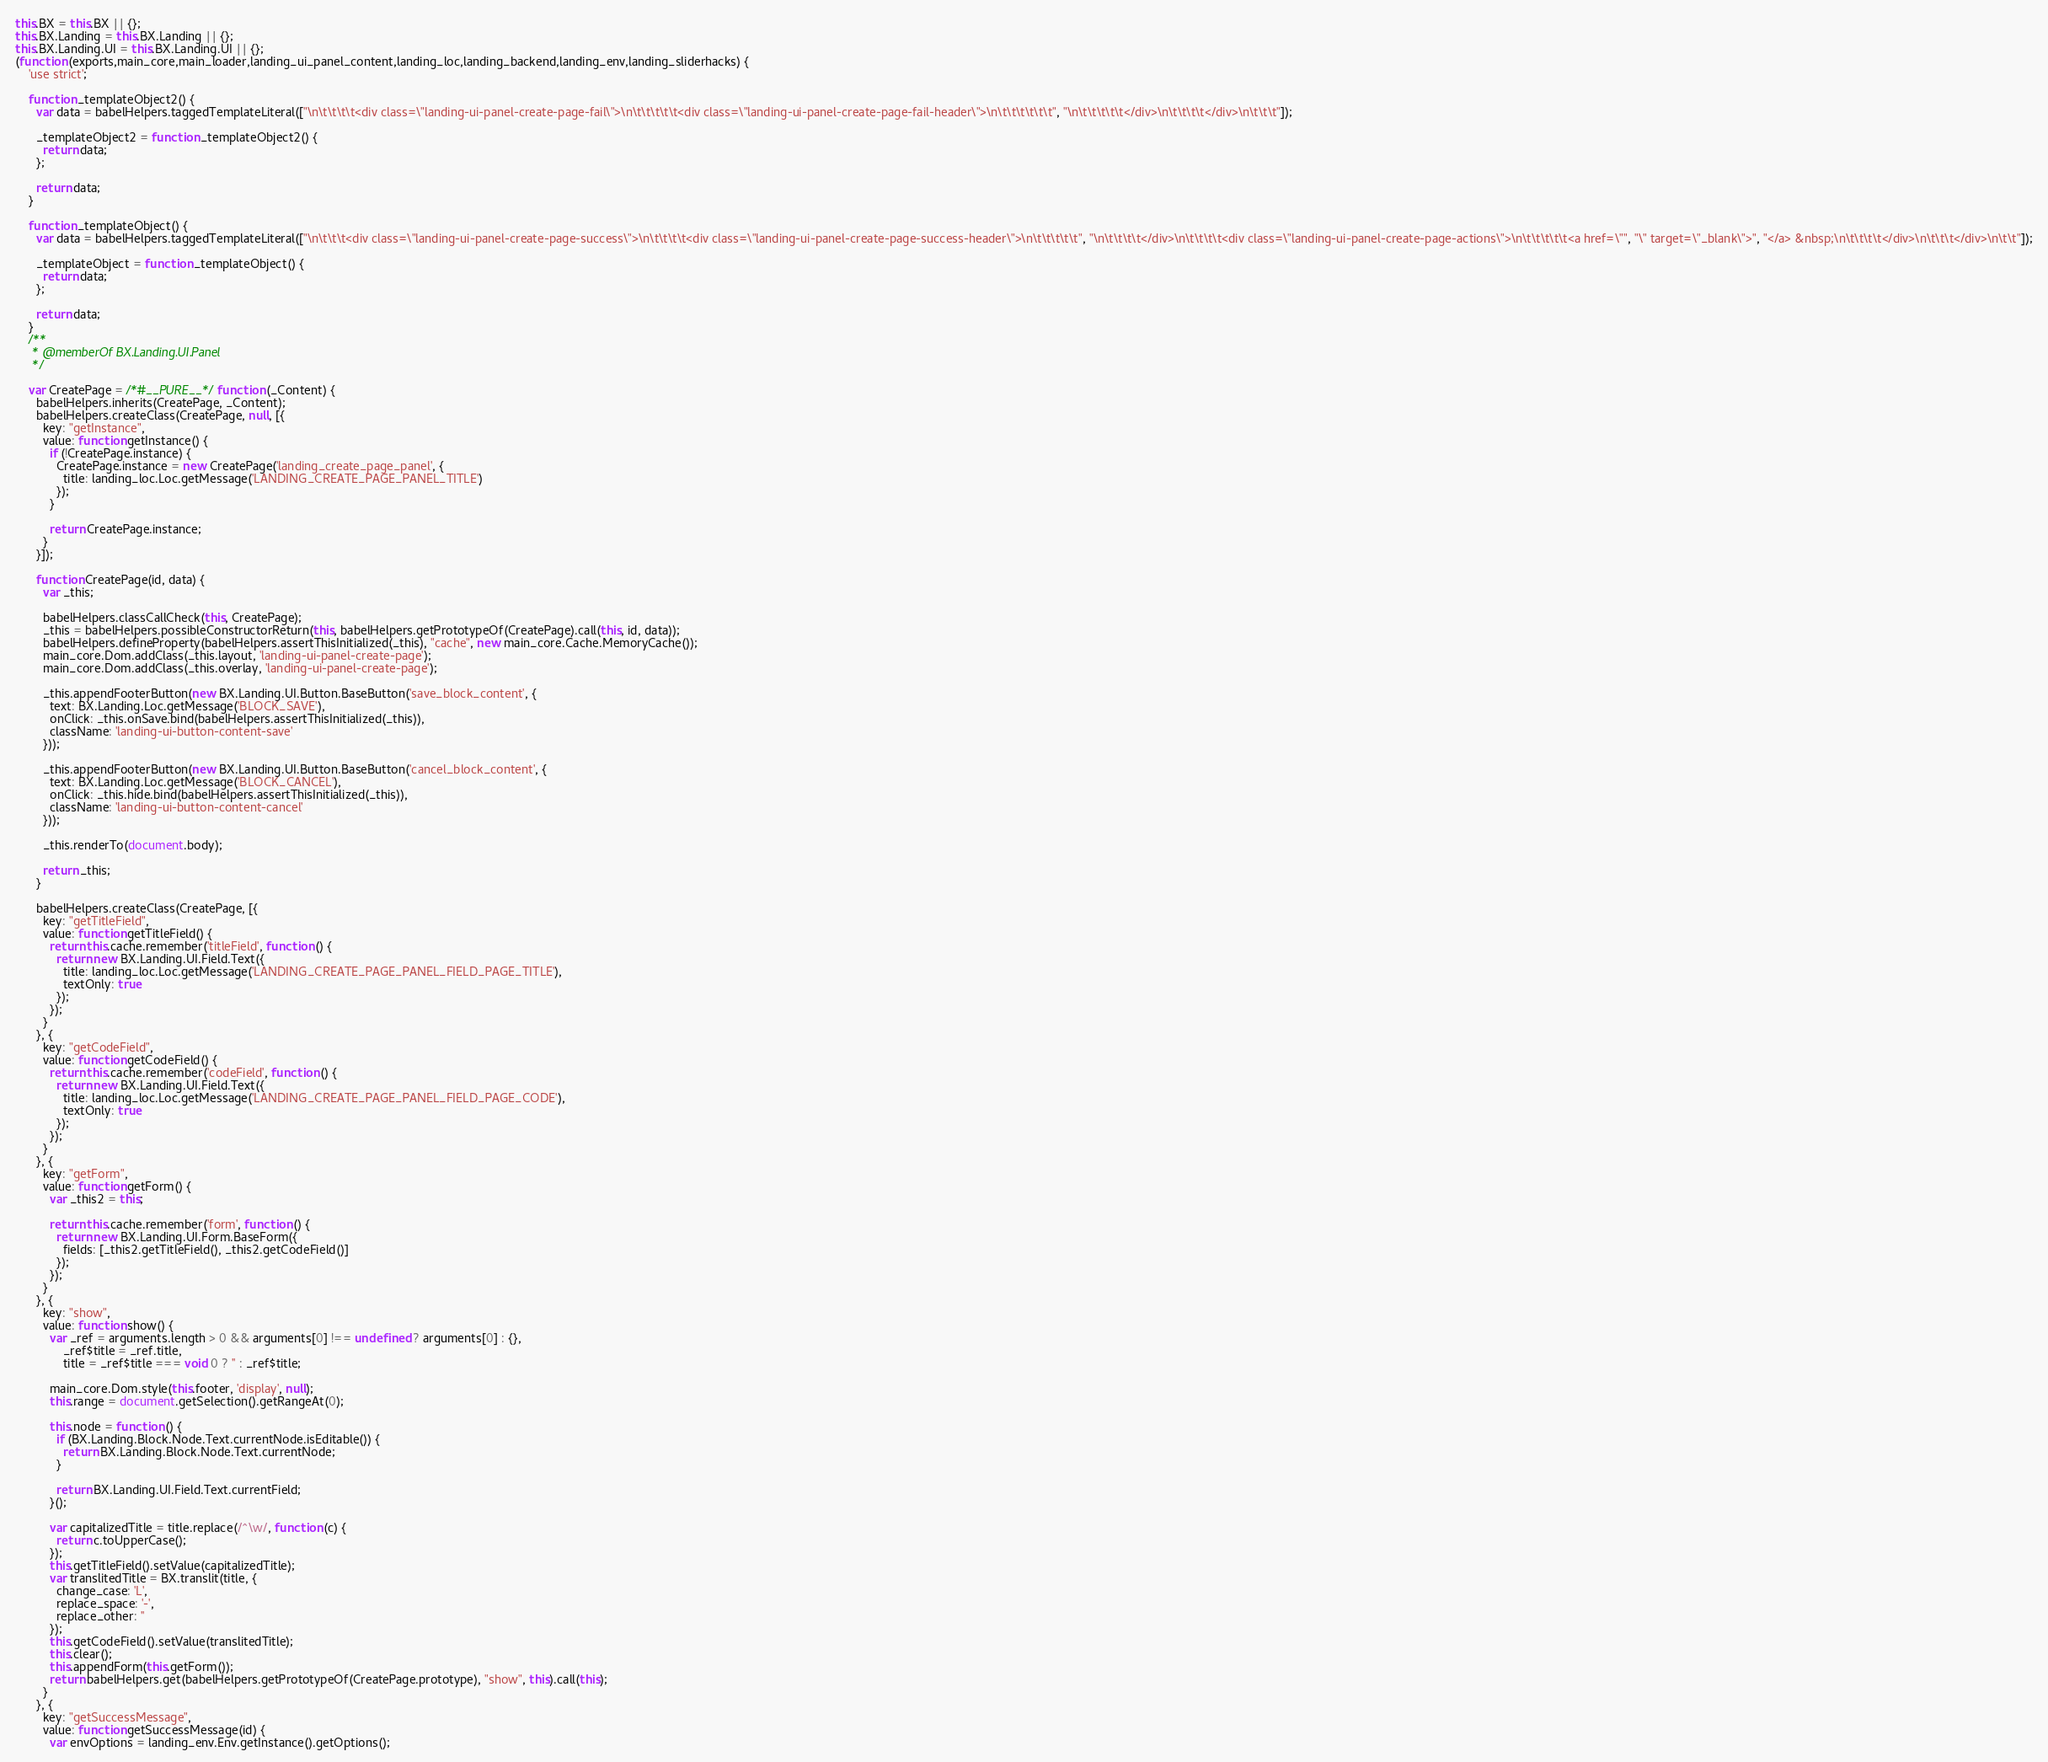<code> <loc_0><loc_0><loc_500><loc_500><_JavaScript_>this.BX = this.BX || {};
this.BX.Landing = this.BX.Landing || {};
this.BX.Landing.UI = this.BX.Landing.UI || {};
(function (exports,main_core,main_loader,landing_ui_panel_content,landing_loc,landing_backend,landing_env,landing_sliderhacks) {
	'use strict';

	function _templateObject2() {
	  var data = babelHelpers.taggedTemplateLiteral(["\n\t\t\t\t<div class=\"landing-ui-panel-create-page-fail\">\n\t\t\t\t\t<div class=\"landing-ui-panel-create-page-fail-header\">\n\t\t\t\t\t\t", "\n\t\t\t\t\t</div>\n\t\t\t\t</div>\n\t\t\t"]);

	  _templateObject2 = function _templateObject2() {
	    return data;
	  };

	  return data;
	}

	function _templateObject() {
	  var data = babelHelpers.taggedTemplateLiteral(["\n\t\t\t<div class=\"landing-ui-panel-create-page-success\">\n\t\t\t\t<div class=\"landing-ui-panel-create-page-success-header\">\n\t\t\t\t\t", "\n\t\t\t\t</div>\n\t\t\t\t<div class=\"landing-ui-panel-create-page-actions\">\n\t\t\t\t\t<a href=\"", "\" target=\"_blank\">", "</a> &nbsp;\n\t\t\t\t</div>\n\t\t\t</div>\n\t\t"]);

	  _templateObject = function _templateObject() {
	    return data;
	  };

	  return data;
	}
	/**
	 * @memberOf BX.Landing.UI.Panel
	 */

	var CreatePage = /*#__PURE__*/function (_Content) {
	  babelHelpers.inherits(CreatePage, _Content);
	  babelHelpers.createClass(CreatePage, null, [{
	    key: "getInstance",
	    value: function getInstance() {
	      if (!CreatePage.instance) {
	        CreatePage.instance = new CreatePage('landing_create_page_panel', {
	          title: landing_loc.Loc.getMessage('LANDING_CREATE_PAGE_PANEL_TITLE')
	        });
	      }

	      return CreatePage.instance;
	    }
	  }]);

	  function CreatePage(id, data) {
	    var _this;

	    babelHelpers.classCallCheck(this, CreatePage);
	    _this = babelHelpers.possibleConstructorReturn(this, babelHelpers.getPrototypeOf(CreatePage).call(this, id, data));
	    babelHelpers.defineProperty(babelHelpers.assertThisInitialized(_this), "cache", new main_core.Cache.MemoryCache());
	    main_core.Dom.addClass(_this.layout, 'landing-ui-panel-create-page');
	    main_core.Dom.addClass(_this.overlay, 'landing-ui-panel-create-page');

	    _this.appendFooterButton(new BX.Landing.UI.Button.BaseButton('save_block_content', {
	      text: BX.Landing.Loc.getMessage('BLOCK_SAVE'),
	      onClick: _this.onSave.bind(babelHelpers.assertThisInitialized(_this)),
	      className: 'landing-ui-button-content-save'
	    }));

	    _this.appendFooterButton(new BX.Landing.UI.Button.BaseButton('cancel_block_content', {
	      text: BX.Landing.Loc.getMessage('BLOCK_CANCEL'),
	      onClick: _this.hide.bind(babelHelpers.assertThisInitialized(_this)),
	      className: 'landing-ui-button-content-cancel'
	    }));

	    _this.renderTo(document.body);

	    return _this;
	  }

	  babelHelpers.createClass(CreatePage, [{
	    key: "getTitleField",
	    value: function getTitleField() {
	      return this.cache.remember('titleField', function () {
	        return new BX.Landing.UI.Field.Text({
	          title: landing_loc.Loc.getMessage('LANDING_CREATE_PAGE_PANEL_FIELD_PAGE_TITLE'),
	          textOnly: true
	        });
	      });
	    }
	  }, {
	    key: "getCodeField",
	    value: function getCodeField() {
	      return this.cache.remember('codeField', function () {
	        return new BX.Landing.UI.Field.Text({
	          title: landing_loc.Loc.getMessage('LANDING_CREATE_PAGE_PANEL_FIELD_PAGE_CODE'),
	          textOnly: true
	        });
	      });
	    }
	  }, {
	    key: "getForm",
	    value: function getForm() {
	      var _this2 = this;

	      return this.cache.remember('form', function () {
	        return new BX.Landing.UI.Form.BaseForm({
	          fields: [_this2.getTitleField(), _this2.getCodeField()]
	        });
	      });
	    }
	  }, {
	    key: "show",
	    value: function show() {
	      var _ref = arguments.length > 0 && arguments[0] !== undefined ? arguments[0] : {},
	          _ref$title = _ref.title,
	          title = _ref$title === void 0 ? '' : _ref$title;

	      main_core.Dom.style(this.footer, 'display', null);
	      this.range = document.getSelection().getRangeAt(0);

	      this.node = function () {
	        if (BX.Landing.Block.Node.Text.currentNode.isEditable()) {
	          return BX.Landing.Block.Node.Text.currentNode;
	        }

	        return BX.Landing.UI.Field.Text.currentField;
	      }();

	      var capitalizedTitle = title.replace(/^\w/, function (c) {
	        return c.toUpperCase();
	      });
	      this.getTitleField().setValue(capitalizedTitle);
	      var translitedTitle = BX.translit(title, {
	        change_case: 'L',
	        replace_space: '-',
	        replace_other: ''
	      });
	      this.getCodeField().setValue(translitedTitle);
	      this.clear();
	      this.appendForm(this.getForm());
	      return babelHelpers.get(babelHelpers.getPrototypeOf(CreatePage.prototype), "show", this).call(this);
	    }
	  }, {
	    key: "getSuccessMessage",
	    value: function getSuccessMessage(id) {
	      var envOptions = landing_env.Env.getInstance().getOptions();</code> 